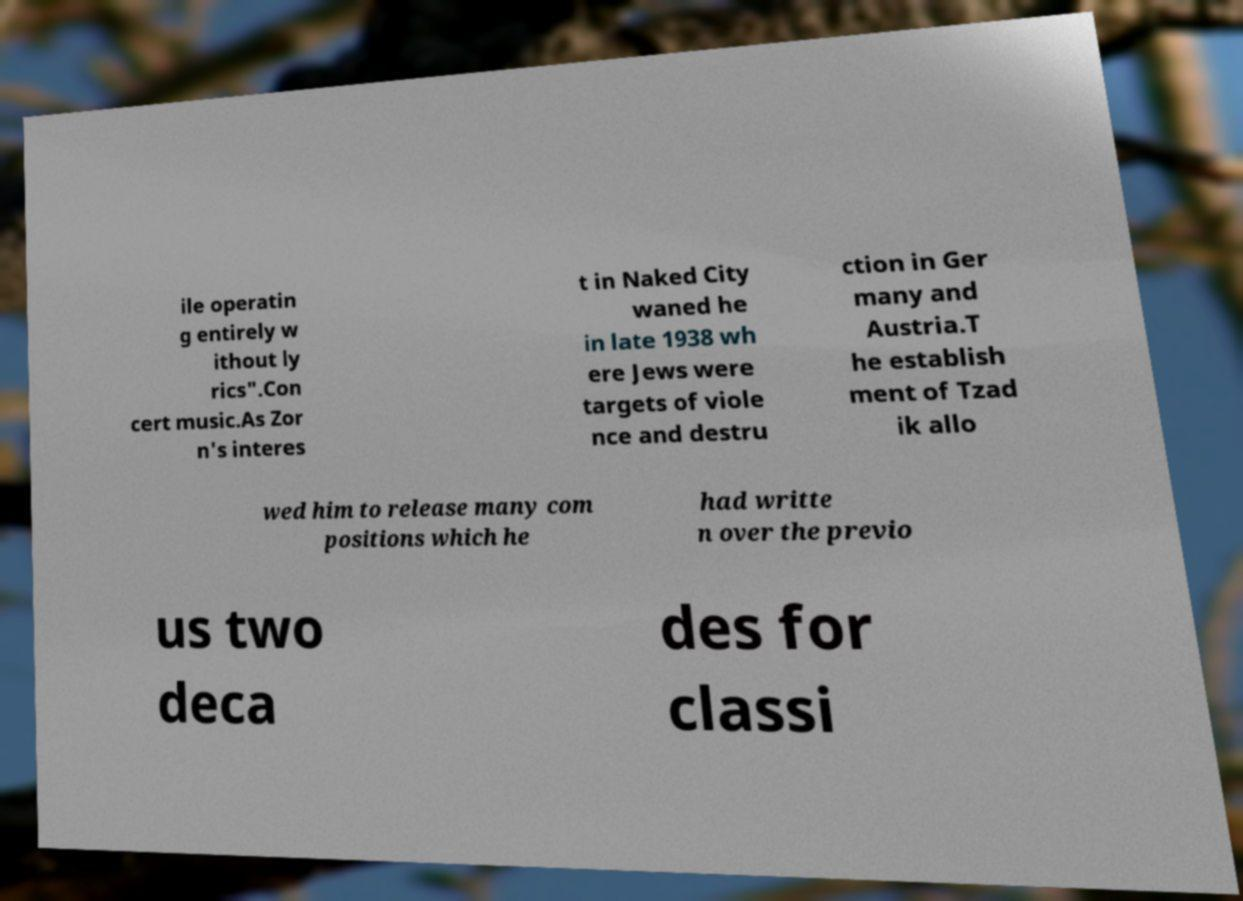Please identify and transcribe the text found in this image. ile operatin g entirely w ithout ly rics".Con cert music.As Zor n's interes t in Naked City waned he in late 1938 wh ere Jews were targets of viole nce and destru ction in Ger many and Austria.T he establish ment of Tzad ik allo wed him to release many com positions which he had writte n over the previo us two deca des for classi 